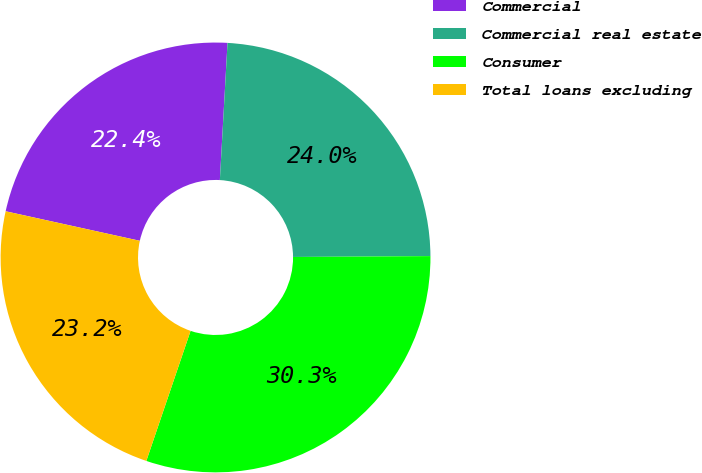<chart> <loc_0><loc_0><loc_500><loc_500><pie_chart><fcel>Commercial<fcel>Commercial real estate<fcel>Consumer<fcel>Total loans excluding<nl><fcel>22.44%<fcel>24.01%<fcel>30.32%<fcel>23.23%<nl></chart> 